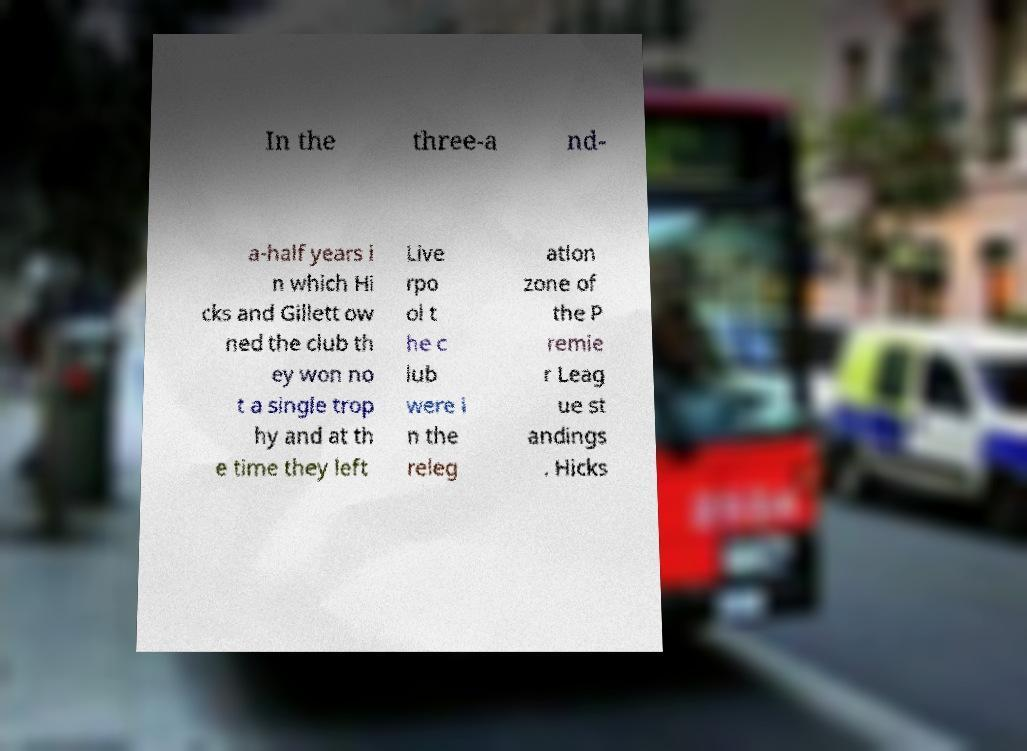For documentation purposes, I need the text within this image transcribed. Could you provide that? In the three-a nd- a-half years i n which Hi cks and Gillett ow ned the club th ey won no t a single trop hy and at th e time they left Live rpo ol t he c lub were i n the releg ation zone of the P remie r Leag ue st andings . Hicks 